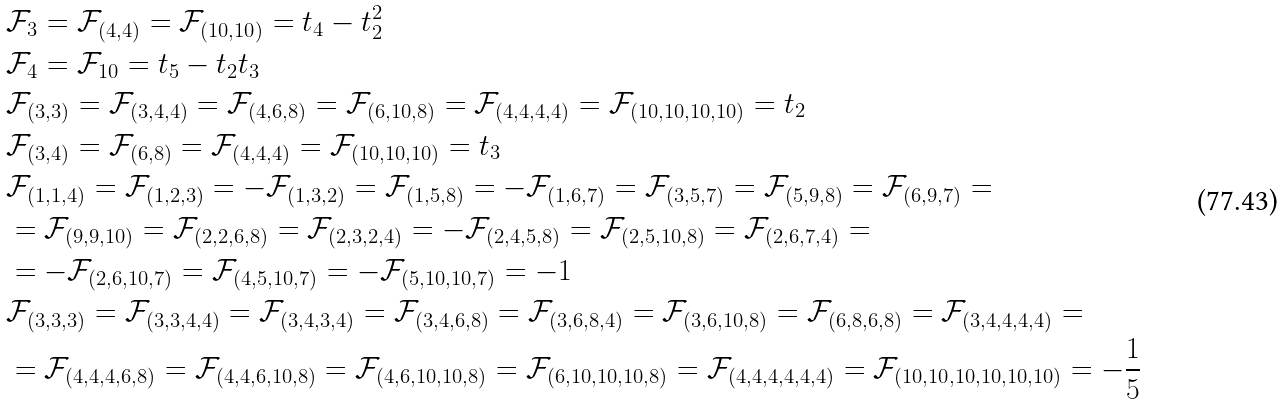<formula> <loc_0><loc_0><loc_500><loc_500>& \mathcal { F } _ { 3 } = \mathcal { F } _ { ( 4 , 4 ) } = \mathcal { F } _ { ( 1 0 , 1 0 ) } = t _ { 4 } - t _ { 2 } ^ { 2 } \\ & \mathcal { F } _ { 4 } = \mathcal { F } _ { 1 0 } = t _ { 5 } - t _ { 2 } t _ { 3 } \\ & \mathcal { F } _ { ( 3 , 3 ) } = \mathcal { F } _ { ( 3 , 4 , 4 ) } = \mathcal { F } _ { ( 4 , 6 , 8 ) } = \mathcal { F } _ { ( 6 , 1 0 , 8 ) } = \mathcal { F } _ { ( 4 , 4 , 4 , 4 ) } = \mathcal { F } _ { ( 1 0 , 1 0 , 1 0 , 1 0 ) } = t _ { 2 } \\ & \mathcal { F } _ { ( 3 , 4 ) } = \mathcal { F } _ { ( 6 , 8 ) } = \mathcal { F } _ { ( 4 , 4 , 4 ) } = \mathcal { F } _ { ( 1 0 , 1 0 , 1 0 ) } = t _ { 3 } \\ & \mathcal { F } _ { ( 1 , 1 , 4 ) } = \mathcal { F } _ { ( 1 , 2 , 3 ) } = - \mathcal { F } _ { ( 1 , 3 , 2 ) } = \mathcal { F } _ { ( 1 , 5 , 8 ) } = - \mathcal { F } _ { ( 1 , 6 , 7 ) } = \mathcal { F } _ { ( 3 , 5 , 7 ) } = \mathcal { F } _ { ( 5 , 9 , 8 ) } = \mathcal { F } _ { ( 6 , 9 , 7 ) } = \\ & = \mathcal { F } _ { ( 9 , 9 , 1 0 ) } = \mathcal { F } _ { ( 2 , 2 , 6 , 8 ) } = \mathcal { F } _ { ( 2 , 3 , 2 , 4 ) } = - \mathcal { F } _ { ( 2 , 4 , 5 , 8 ) } = \mathcal { F } _ { ( 2 , 5 , 1 0 , 8 ) } = \mathcal { F } _ { ( 2 , 6 , 7 , 4 ) } = \\ & = - \mathcal { F } _ { ( 2 , 6 , 1 0 , 7 ) } = \mathcal { F } _ { ( 4 , 5 , 1 0 , 7 ) } = - \mathcal { F } _ { ( 5 , 1 0 , 1 0 , 7 ) } = - 1 \\ & \mathcal { F } _ { ( 3 , 3 , 3 ) } = \mathcal { F } _ { ( 3 , 3 , 4 , 4 ) } = \mathcal { F } _ { ( 3 , 4 , 3 , 4 ) } = \mathcal { F } _ { ( 3 , 4 , 6 , 8 ) } = \mathcal { F } _ { ( 3 , 6 , 8 , 4 ) } = \mathcal { F } _ { ( 3 , 6 , 1 0 , 8 ) } = \mathcal { F } _ { ( 6 , 8 , 6 , 8 ) } = \mathcal { F } _ { ( 3 , 4 , 4 , 4 , 4 ) } = \\ & = \mathcal { F } _ { ( 4 , 4 , 4 , 6 , 8 ) } = \mathcal { F } _ { ( 4 , 4 , 6 , 1 0 , 8 ) } = \mathcal { F } _ { ( 4 , 6 , 1 0 , 1 0 , 8 ) } = \mathcal { F } _ { ( 6 , 1 0 , 1 0 , 1 0 , 8 ) } = \mathcal { F } _ { ( 4 , 4 , 4 , 4 , 4 , 4 ) } = \mathcal { F } _ { ( 1 0 , 1 0 , 1 0 , 1 0 , 1 0 , 1 0 ) } = - \frac { 1 } { 5 }</formula> 